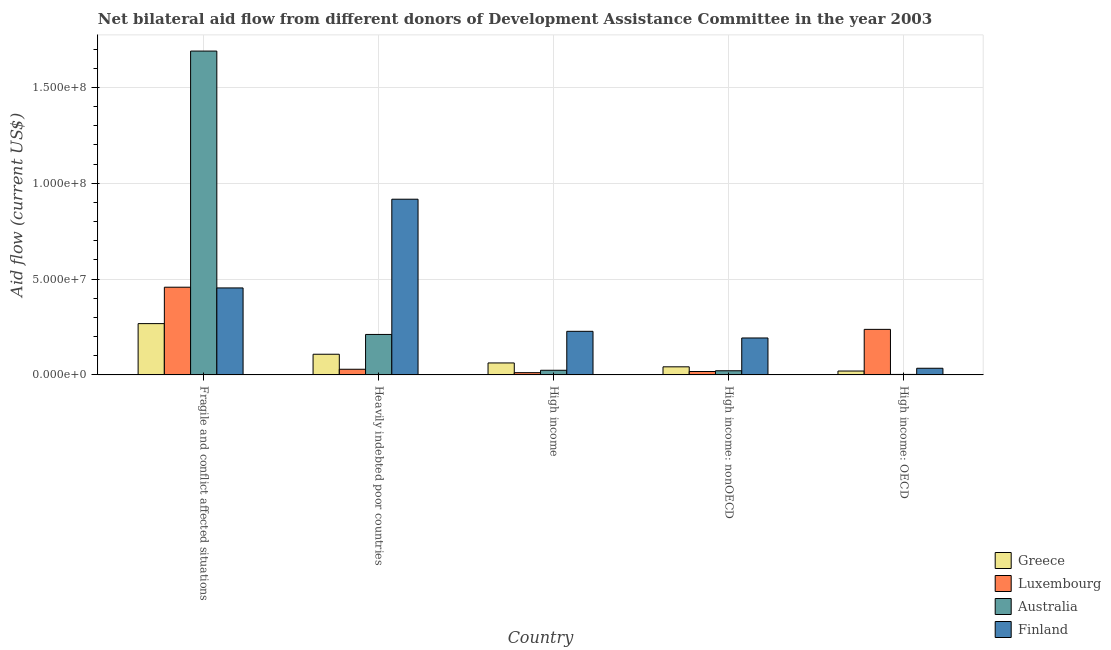How many different coloured bars are there?
Ensure brevity in your answer.  4. Are the number of bars per tick equal to the number of legend labels?
Offer a very short reply. Yes. How many bars are there on the 4th tick from the left?
Your response must be concise. 4. How many bars are there on the 4th tick from the right?
Your response must be concise. 4. What is the label of the 3rd group of bars from the left?
Offer a very short reply. High income. What is the amount of aid given by greece in High income: OECD?
Make the answer very short. 2.02e+06. Across all countries, what is the maximum amount of aid given by luxembourg?
Your answer should be very brief. 4.58e+07. Across all countries, what is the minimum amount of aid given by finland?
Ensure brevity in your answer.  3.47e+06. In which country was the amount of aid given by luxembourg maximum?
Provide a short and direct response. Fragile and conflict affected situations. In which country was the amount of aid given by greece minimum?
Make the answer very short. High income: OECD. What is the total amount of aid given by finland in the graph?
Your response must be concise. 1.83e+08. What is the difference between the amount of aid given by greece in High income and that in High income: OECD?
Give a very brief answer. 4.22e+06. What is the difference between the amount of aid given by australia in High income and the amount of aid given by finland in Fragile and conflict affected situations?
Make the answer very short. -4.30e+07. What is the average amount of aid given by luxembourg per country?
Provide a short and direct response. 1.51e+07. What is the difference between the amount of aid given by luxembourg and amount of aid given by australia in High income: OECD?
Keep it short and to the point. 2.35e+07. What is the ratio of the amount of aid given by luxembourg in Heavily indebted poor countries to that in High income: OECD?
Your answer should be compact. 0.12. Is the amount of aid given by greece in Heavily indebted poor countries less than that in High income: OECD?
Give a very brief answer. No. What is the difference between the highest and the second highest amount of aid given by luxembourg?
Offer a terse response. 2.20e+07. What is the difference between the highest and the lowest amount of aid given by australia?
Your response must be concise. 1.69e+08. Is the sum of the amount of aid given by finland in Heavily indebted poor countries and High income: OECD greater than the maximum amount of aid given by luxembourg across all countries?
Offer a terse response. Yes. Is it the case that in every country, the sum of the amount of aid given by luxembourg and amount of aid given by greece is greater than the sum of amount of aid given by finland and amount of aid given by australia?
Keep it short and to the point. No. What does the 2nd bar from the right in High income: OECD represents?
Offer a very short reply. Australia. Is it the case that in every country, the sum of the amount of aid given by greece and amount of aid given by luxembourg is greater than the amount of aid given by australia?
Give a very brief answer. No. How many bars are there?
Offer a very short reply. 20. How many countries are there in the graph?
Make the answer very short. 5. What is the difference between two consecutive major ticks on the Y-axis?
Provide a succinct answer. 5.00e+07. Does the graph contain grids?
Give a very brief answer. Yes. Where does the legend appear in the graph?
Your answer should be very brief. Bottom right. How many legend labels are there?
Give a very brief answer. 4. How are the legend labels stacked?
Keep it short and to the point. Vertical. What is the title of the graph?
Your response must be concise. Net bilateral aid flow from different donors of Development Assistance Committee in the year 2003. Does "UNRWA" appear as one of the legend labels in the graph?
Ensure brevity in your answer.  No. What is the label or title of the X-axis?
Your answer should be very brief. Country. What is the Aid flow (current US$) of Greece in Fragile and conflict affected situations?
Your answer should be very brief. 2.68e+07. What is the Aid flow (current US$) in Luxembourg in Fragile and conflict affected situations?
Offer a terse response. 4.58e+07. What is the Aid flow (current US$) of Australia in Fragile and conflict affected situations?
Offer a very short reply. 1.69e+08. What is the Aid flow (current US$) of Finland in Fragile and conflict affected situations?
Your answer should be compact. 4.54e+07. What is the Aid flow (current US$) of Greece in Heavily indebted poor countries?
Offer a very short reply. 1.08e+07. What is the Aid flow (current US$) in Luxembourg in Heavily indebted poor countries?
Offer a terse response. 2.95e+06. What is the Aid flow (current US$) in Australia in Heavily indebted poor countries?
Keep it short and to the point. 2.11e+07. What is the Aid flow (current US$) of Finland in Heavily indebted poor countries?
Make the answer very short. 9.17e+07. What is the Aid flow (current US$) of Greece in High income?
Provide a succinct answer. 6.24e+06. What is the Aid flow (current US$) of Luxembourg in High income?
Your answer should be compact. 1.17e+06. What is the Aid flow (current US$) of Australia in High income?
Your answer should be compact. 2.42e+06. What is the Aid flow (current US$) in Finland in High income?
Give a very brief answer. 2.27e+07. What is the Aid flow (current US$) of Greece in High income: nonOECD?
Offer a terse response. 4.22e+06. What is the Aid flow (current US$) of Luxembourg in High income: nonOECD?
Make the answer very short. 1.78e+06. What is the Aid flow (current US$) in Australia in High income: nonOECD?
Offer a terse response. 2.17e+06. What is the Aid flow (current US$) of Finland in High income: nonOECD?
Offer a very short reply. 1.93e+07. What is the Aid flow (current US$) of Greece in High income: OECD?
Your answer should be compact. 2.02e+06. What is the Aid flow (current US$) of Luxembourg in High income: OECD?
Offer a very short reply. 2.38e+07. What is the Aid flow (current US$) in Finland in High income: OECD?
Provide a short and direct response. 3.47e+06. Across all countries, what is the maximum Aid flow (current US$) of Greece?
Offer a very short reply. 2.68e+07. Across all countries, what is the maximum Aid flow (current US$) in Luxembourg?
Your response must be concise. 4.58e+07. Across all countries, what is the maximum Aid flow (current US$) of Australia?
Give a very brief answer. 1.69e+08. Across all countries, what is the maximum Aid flow (current US$) in Finland?
Ensure brevity in your answer.  9.17e+07. Across all countries, what is the minimum Aid flow (current US$) in Greece?
Make the answer very short. 2.02e+06. Across all countries, what is the minimum Aid flow (current US$) of Luxembourg?
Your answer should be compact. 1.17e+06. Across all countries, what is the minimum Aid flow (current US$) of Australia?
Ensure brevity in your answer.  2.50e+05. Across all countries, what is the minimum Aid flow (current US$) in Finland?
Keep it short and to the point. 3.47e+06. What is the total Aid flow (current US$) of Greece in the graph?
Make the answer very short. 5.00e+07. What is the total Aid flow (current US$) of Luxembourg in the graph?
Offer a very short reply. 7.54e+07. What is the total Aid flow (current US$) in Australia in the graph?
Your response must be concise. 1.95e+08. What is the total Aid flow (current US$) in Finland in the graph?
Make the answer very short. 1.83e+08. What is the difference between the Aid flow (current US$) in Greece in Fragile and conflict affected situations and that in Heavily indebted poor countries?
Offer a very short reply. 1.60e+07. What is the difference between the Aid flow (current US$) of Luxembourg in Fragile and conflict affected situations and that in Heavily indebted poor countries?
Ensure brevity in your answer.  4.28e+07. What is the difference between the Aid flow (current US$) of Australia in Fragile and conflict affected situations and that in Heavily indebted poor countries?
Give a very brief answer. 1.48e+08. What is the difference between the Aid flow (current US$) of Finland in Fragile and conflict affected situations and that in Heavily indebted poor countries?
Give a very brief answer. -4.63e+07. What is the difference between the Aid flow (current US$) in Greece in Fragile and conflict affected situations and that in High income?
Your response must be concise. 2.05e+07. What is the difference between the Aid flow (current US$) of Luxembourg in Fragile and conflict affected situations and that in High income?
Offer a very short reply. 4.46e+07. What is the difference between the Aid flow (current US$) of Australia in Fragile and conflict affected situations and that in High income?
Ensure brevity in your answer.  1.67e+08. What is the difference between the Aid flow (current US$) in Finland in Fragile and conflict affected situations and that in High income?
Give a very brief answer. 2.26e+07. What is the difference between the Aid flow (current US$) of Greece in Fragile and conflict affected situations and that in High income: nonOECD?
Your answer should be compact. 2.25e+07. What is the difference between the Aid flow (current US$) of Luxembourg in Fragile and conflict affected situations and that in High income: nonOECD?
Your answer should be very brief. 4.40e+07. What is the difference between the Aid flow (current US$) in Australia in Fragile and conflict affected situations and that in High income: nonOECD?
Ensure brevity in your answer.  1.67e+08. What is the difference between the Aid flow (current US$) of Finland in Fragile and conflict affected situations and that in High income: nonOECD?
Make the answer very short. 2.61e+07. What is the difference between the Aid flow (current US$) in Greece in Fragile and conflict affected situations and that in High income: OECD?
Your answer should be compact. 2.47e+07. What is the difference between the Aid flow (current US$) of Luxembourg in Fragile and conflict affected situations and that in High income: OECD?
Ensure brevity in your answer.  2.20e+07. What is the difference between the Aid flow (current US$) in Australia in Fragile and conflict affected situations and that in High income: OECD?
Provide a short and direct response. 1.69e+08. What is the difference between the Aid flow (current US$) of Finland in Fragile and conflict affected situations and that in High income: OECD?
Provide a short and direct response. 4.19e+07. What is the difference between the Aid flow (current US$) of Greece in Heavily indebted poor countries and that in High income?
Ensure brevity in your answer.  4.54e+06. What is the difference between the Aid flow (current US$) of Luxembourg in Heavily indebted poor countries and that in High income?
Your answer should be compact. 1.78e+06. What is the difference between the Aid flow (current US$) of Australia in Heavily indebted poor countries and that in High income?
Your answer should be compact. 1.87e+07. What is the difference between the Aid flow (current US$) of Finland in Heavily indebted poor countries and that in High income?
Provide a short and direct response. 6.89e+07. What is the difference between the Aid flow (current US$) in Greece in Heavily indebted poor countries and that in High income: nonOECD?
Provide a succinct answer. 6.56e+06. What is the difference between the Aid flow (current US$) in Luxembourg in Heavily indebted poor countries and that in High income: nonOECD?
Offer a very short reply. 1.17e+06. What is the difference between the Aid flow (current US$) of Australia in Heavily indebted poor countries and that in High income: nonOECD?
Your answer should be very brief. 1.89e+07. What is the difference between the Aid flow (current US$) of Finland in Heavily indebted poor countries and that in High income: nonOECD?
Your answer should be very brief. 7.24e+07. What is the difference between the Aid flow (current US$) in Greece in Heavily indebted poor countries and that in High income: OECD?
Your response must be concise. 8.76e+06. What is the difference between the Aid flow (current US$) of Luxembourg in Heavily indebted poor countries and that in High income: OECD?
Ensure brevity in your answer.  -2.08e+07. What is the difference between the Aid flow (current US$) of Australia in Heavily indebted poor countries and that in High income: OECD?
Offer a very short reply. 2.09e+07. What is the difference between the Aid flow (current US$) in Finland in Heavily indebted poor countries and that in High income: OECD?
Your answer should be very brief. 8.82e+07. What is the difference between the Aid flow (current US$) in Greece in High income and that in High income: nonOECD?
Provide a short and direct response. 2.02e+06. What is the difference between the Aid flow (current US$) in Luxembourg in High income and that in High income: nonOECD?
Provide a short and direct response. -6.10e+05. What is the difference between the Aid flow (current US$) of Finland in High income and that in High income: nonOECD?
Provide a short and direct response. 3.47e+06. What is the difference between the Aid flow (current US$) of Greece in High income and that in High income: OECD?
Keep it short and to the point. 4.22e+06. What is the difference between the Aid flow (current US$) in Luxembourg in High income and that in High income: OECD?
Provide a succinct answer. -2.26e+07. What is the difference between the Aid flow (current US$) in Australia in High income and that in High income: OECD?
Offer a very short reply. 2.17e+06. What is the difference between the Aid flow (current US$) of Finland in High income and that in High income: OECD?
Offer a very short reply. 1.93e+07. What is the difference between the Aid flow (current US$) in Greece in High income: nonOECD and that in High income: OECD?
Offer a terse response. 2.20e+06. What is the difference between the Aid flow (current US$) in Luxembourg in High income: nonOECD and that in High income: OECD?
Keep it short and to the point. -2.20e+07. What is the difference between the Aid flow (current US$) in Australia in High income: nonOECD and that in High income: OECD?
Provide a succinct answer. 1.92e+06. What is the difference between the Aid flow (current US$) of Finland in High income: nonOECD and that in High income: OECD?
Make the answer very short. 1.58e+07. What is the difference between the Aid flow (current US$) in Greece in Fragile and conflict affected situations and the Aid flow (current US$) in Luxembourg in Heavily indebted poor countries?
Keep it short and to the point. 2.38e+07. What is the difference between the Aid flow (current US$) of Greece in Fragile and conflict affected situations and the Aid flow (current US$) of Australia in Heavily indebted poor countries?
Your answer should be very brief. 5.65e+06. What is the difference between the Aid flow (current US$) of Greece in Fragile and conflict affected situations and the Aid flow (current US$) of Finland in Heavily indebted poor countries?
Ensure brevity in your answer.  -6.49e+07. What is the difference between the Aid flow (current US$) in Luxembourg in Fragile and conflict affected situations and the Aid flow (current US$) in Australia in Heavily indebted poor countries?
Offer a very short reply. 2.46e+07. What is the difference between the Aid flow (current US$) of Luxembourg in Fragile and conflict affected situations and the Aid flow (current US$) of Finland in Heavily indebted poor countries?
Make the answer very short. -4.59e+07. What is the difference between the Aid flow (current US$) in Australia in Fragile and conflict affected situations and the Aid flow (current US$) in Finland in Heavily indebted poor countries?
Ensure brevity in your answer.  7.73e+07. What is the difference between the Aid flow (current US$) of Greece in Fragile and conflict affected situations and the Aid flow (current US$) of Luxembourg in High income?
Your answer should be very brief. 2.56e+07. What is the difference between the Aid flow (current US$) of Greece in Fragile and conflict affected situations and the Aid flow (current US$) of Australia in High income?
Give a very brief answer. 2.43e+07. What is the difference between the Aid flow (current US$) in Greece in Fragile and conflict affected situations and the Aid flow (current US$) in Finland in High income?
Make the answer very short. 4.02e+06. What is the difference between the Aid flow (current US$) in Luxembourg in Fragile and conflict affected situations and the Aid flow (current US$) in Australia in High income?
Keep it short and to the point. 4.33e+07. What is the difference between the Aid flow (current US$) of Luxembourg in Fragile and conflict affected situations and the Aid flow (current US$) of Finland in High income?
Your answer should be very brief. 2.30e+07. What is the difference between the Aid flow (current US$) in Australia in Fragile and conflict affected situations and the Aid flow (current US$) in Finland in High income?
Your answer should be compact. 1.46e+08. What is the difference between the Aid flow (current US$) of Greece in Fragile and conflict affected situations and the Aid flow (current US$) of Luxembourg in High income: nonOECD?
Your answer should be very brief. 2.50e+07. What is the difference between the Aid flow (current US$) of Greece in Fragile and conflict affected situations and the Aid flow (current US$) of Australia in High income: nonOECD?
Ensure brevity in your answer.  2.46e+07. What is the difference between the Aid flow (current US$) in Greece in Fragile and conflict affected situations and the Aid flow (current US$) in Finland in High income: nonOECD?
Ensure brevity in your answer.  7.49e+06. What is the difference between the Aid flow (current US$) in Luxembourg in Fragile and conflict affected situations and the Aid flow (current US$) in Australia in High income: nonOECD?
Give a very brief answer. 4.36e+07. What is the difference between the Aid flow (current US$) in Luxembourg in Fragile and conflict affected situations and the Aid flow (current US$) in Finland in High income: nonOECD?
Provide a short and direct response. 2.65e+07. What is the difference between the Aid flow (current US$) of Australia in Fragile and conflict affected situations and the Aid flow (current US$) of Finland in High income: nonOECD?
Make the answer very short. 1.50e+08. What is the difference between the Aid flow (current US$) in Greece in Fragile and conflict affected situations and the Aid flow (current US$) in Australia in High income: OECD?
Keep it short and to the point. 2.65e+07. What is the difference between the Aid flow (current US$) of Greece in Fragile and conflict affected situations and the Aid flow (current US$) of Finland in High income: OECD?
Provide a succinct answer. 2.33e+07. What is the difference between the Aid flow (current US$) in Luxembourg in Fragile and conflict affected situations and the Aid flow (current US$) in Australia in High income: OECD?
Make the answer very short. 4.55e+07. What is the difference between the Aid flow (current US$) in Luxembourg in Fragile and conflict affected situations and the Aid flow (current US$) in Finland in High income: OECD?
Your response must be concise. 4.23e+07. What is the difference between the Aid flow (current US$) in Australia in Fragile and conflict affected situations and the Aid flow (current US$) in Finland in High income: OECD?
Provide a succinct answer. 1.65e+08. What is the difference between the Aid flow (current US$) in Greece in Heavily indebted poor countries and the Aid flow (current US$) in Luxembourg in High income?
Offer a terse response. 9.61e+06. What is the difference between the Aid flow (current US$) in Greece in Heavily indebted poor countries and the Aid flow (current US$) in Australia in High income?
Your response must be concise. 8.36e+06. What is the difference between the Aid flow (current US$) in Greece in Heavily indebted poor countries and the Aid flow (current US$) in Finland in High income?
Give a very brief answer. -1.20e+07. What is the difference between the Aid flow (current US$) of Luxembourg in Heavily indebted poor countries and the Aid flow (current US$) of Australia in High income?
Offer a terse response. 5.30e+05. What is the difference between the Aid flow (current US$) of Luxembourg in Heavily indebted poor countries and the Aid flow (current US$) of Finland in High income?
Your answer should be very brief. -1.98e+07. What is the difference between the Aid flow (current US$) of Australia in Heavily indebted poor countries and the Aid flow (current US$) of Finland in High income?
Provide a short and direct response. -1.63e+06. What is the difference between the Aid flow (current US$) in Greece in Heavily indebted poor countries and the Aid flow (current US$) in Luxembourg in High income: nonOECD?
Your answer should be very brief. 9.00e+06. What is the difference between the Aid flow (current US$) of Greece in Heavily indebted poor countries and the Aid flow (current US$) of Australia in High income: nonOECD?
Ensure brevity in your answer.  8.61e+06. What is the difference between the Aid flow (current US$) in Greece in Heavily indebted poor countries and the Aid flow (current US$) in Finland in High income: nonOECD?
Your answer should be compact. -8.49e+06. What is the difference between the Aid flow (current US$) of Luxembourg in Heavily indebted poor countries and the Aid flow (current US$) of Australia in High income: nonOECD?
Keep it short and to the point. 7.80e+05. What is the difference between the Aid flow (current US$) of Luxembourg in Heavily indebted poor countries and the Aid flow (current US$) of Finland in High income: nonOECD?
Offer a terse response. -1.63e+07. What is the difference between the Aid flow (current US$) of Australia in Heavily indebted poor countries and the Aid flow (current US$) of Finland in High income: nonOECD?
Offer a terse response. 1.84e+06. What is the difference between the Aid flow (current US$) in Greece in Heavily indebted poor countries and the Aid flow (current US$) in Luxembourg in High income: OECD?
Offer a terse response. -1.30e+07. What is the difference between the Aid flow (current US$) of Greece in Heavily indebted poor countries and the Aid flow (current US$) of Australia in High income: OECD?
Offer a very short reply. 1.05e+07. What is the difference between the Aid flow (current US$) of Greece in Heavily indebted poor countries and the Aid flow (current US$) of Finland in High income: OECD?
Ensure brevity in your answer.  7.31e+06. What is the difference between the Aid flow (current US$) in Luxembourg in Heavily indebted poor countries and the Aid flow (current US$) in Australia in High income: OECD?
Your answer should be compact. 2.70e+06. What is the difference between the Aid flow (current US$) in Luxembourg in Heavily indebted poor countries and the Aid flow (current US$) in Finland in High income: OECD?
Offer a very short reply. -5.20e+05. What is the difference between the Aid flow (current US$) of Australia in Heavily indebted poor countries and the Aid flow (current US$) of Finland in High income: OECD?
Offer a terse response. 1.76e+07. What is the difference between the Aid flow (current US$) of Greece in High income and the Aid flow (current US$) of Luxembourg in High income: nonOECD?
Your response must be concise. 4.46e+06. What is the difference between the Aid flow (current US$) in Greece in High income and the Aid flow (current US$) in Australia in High income: nonOECD?
Give a very brief answer. 4.07e+06. What is the difference between the Aid flow (current US$) of Greece in High income and the Aid flow (current US$) of Finland in High income: nonOECD?
Keep it short and to the point. -1.30e+07. What is the difference between the Aid flow (current US$) in Luxembourg in High income and the Aid flow (current US$) in Australia in High income: nonOECD?
Provide a short and direct response. -1.00e+06. What is the difference between the Aid flow (current US$) in Luxembourg in High income and the Aid flow (current US$) in Finland in High income: nonOECD?
Make the answer very short. -1.81e+07. What is the difference between the Aid flow (current US$) in Australia in High income and the Aid flow (current US$) in Finland in High income: nonOECD?
Provide a succinct answer. -1.68e+07. What is the difference between the Aid flow (current US$) in Greece in High income and the Aid flow (current US$) in Luxembourg in High income: OECD?
Your response must be concise. -1.75e+07. What is the difference between the Aid flow (current US$) of Greece in High income and the Aid flow (current US$) of Australia in High income: OECD?
Your answer should be compact. 5.99e+06. What is the difference between the Aid flow (current US$) of Greece in High income and the Aid flow (current US$) of Finland in High income: OECD?
Ensure brevity in your answer.  2.77e+06. What is the difference between the Aid flow (current US$) in Luxembourg in High income and the Aid flow (current US$) in Australia in High income: OECD?
Your response must be concise. 9.20e+05. What is the difference between the Aid flow (current US$) in Luxembourg in High income and the Aid flow (current US$) in Finland in High income: OECD?
Provide a succinct answer. -2.30e+06. What is the difference between the Aid flow (current US$) in Australia in High income and the Aid flow (current US$) in Finland in High income: OECD?
Your answer should be compact. -1.05e+06. What is the difference between the Aid flow (current US$) of Greece in High income: nonOECD and the Aid flow (current US$) of Luxembourg in High income: OECD?
Your answer should be very brief. -1.95e+07. What is the difference between the Aid flow (current US$) in Greece in High income: nonOECD and the Aid flow (current US$) in Australia in High income: OECD?
Ensure brevity in your answer.  3.97e+06. What is the difference between the Aid flow (current US$) in Greece in High income: nonOECD and the Aid flow (current US$) in Finland in High income: OECD?
Keep it short and to the point. 7.50e+05. What is the difference between the Aid flow (current US$) in Luxembourg in High income: nonOECD and the Aid flow (current US$) in Australia in High income: OECD?
Offer a terse response. 1.53e+06. What is the difference between the Aid flow (current US$) of Luxembourg in High income: nonOECD and the Aid flow (current US$) of Finland in High income: OECD?
Provide a short and direct response. -1.69e+06. What is the difference between the Aid flow (current US$) of Australia in High income: nonOECD and the Aid flow (current US$) of Finland in High income: OECD?
Your answer should be compact. -1.30e+06. What is the average Aid flow (current US$) of Greece per country?
Your answer should be very brief. 1.00e+07. What is the average Aid flow (current US$) in Luxembourg per country?
Ensure brevity in your answer.  1.51e+07. What is the average Aid flow (current US$) of Australia per country?
Offer a terse response. 3.90e+07. What is the average Aid flow (current US$) of Finland per country?
Your answer should be very brief. 3.65e+07. What is the difference between the Aid flow (current US$) of Greece and Aid flow (current US$) of Luxembourg in Fragile and conflict affected situations?
Provide a succinct answer. -1.90e+07. What is the difference between the Aid flow (current US$) in Greece and Aid flow (current US$) in Australia in Fragile and conflict affected situations?
Ensure brevity in your answer.  -1.42e+08. What is the difference between the Aid flow (current US$) in Greece and Aid flow (current US$) in Finland in Fragile and conflict affected situations?
Offer a terse response. -1.86e+07. What is the difference between the Aid flow (current US$) of Luxembourg and Aid flow (current US$) of Australia in Fragile and conflict affected situations?
Make the answer very short. -1.23e+08. What is the difference between the Aid flow (current US$) in Luxembourg and Aid flow (current US$) in Finland in Fragile and conflict affected situations?
Offer a very short reply. 3.80e+05. What is the difference between the Aid flow (current US$) of Australia and Aid flow (current US$) of Finland in Fragile and conflict affected situations?
Offer a terse response. 1.24e+08. What is the difference between the Aid flow (current US$) of Greece and Aid flow (current US$) of Luxembourg in Heavily indebted poor countries?
Ensure brevity in your answer.  7.83e+06. What is the difference between the Aid flow (current US$) in Greece and Aid flow (current US$) in Australia in Heavily indebted poor countries?
Make the answer very short. -1.03e+07. What is the difference between the Aid flow (current US$) in Greece and Aid flow (current US$) in Finland in Heavily indebted poor countries?
Provide a succinct answer. -8.09e+07. What is the difference between the Aid flow (current US$) of Luxembourg and Aid flow (current US$) of Australia in Heavily indebted poor countries?
Offer a terse response. -1.82e+07. What is the difference between the Aid flow (current US$) of Luxembourg and Aid flow (current US$) of Finland in Heavily indebted poor countries?
Offer a terse response. -8.87e+07. What is the difference between the Aid flow (current US$) in Australia and Aid flow (current US$) in Finland in Heavily indebted poor countries?
Your response must be concise. -7.06e+07. What is the difference between the Aid flow (current US$) of Greece and Aid flow (current US$) of Luxembourg in High income?
Provide a succinct answer. 5.07e+06. What is the difference between the Aid flow (current US$) of Greece and Aid flow (current US$) of Australia in High income?
Your answer should be very brief. 3.82e+06. What is the difference between the Aid flow (current US$) of Greece and Aid flow (current US$) of Finland in High income?
Your answer should be compact. -1.65e+07. What is the difference between the Aid flow (current US$) of Luxembourg and Aid flow (current US$) of Australia in High income?
Ensure brevity in your answer.  -1.25e+06. What is the difference between the Aid flow (current US$) of Luxembourg and Aid flow (current US$) of Finland in High income?
Provide a short and direct response. -2.16e+07. What is the difference between the Aid flow (current US$) in Australia and Aid flow (current US$) in Finland in High income?
Make the answer very short. -2.03e+07. What is the difference between the Aid flow (current US$) in Greece and Aid flow (current US$) in Luxembourg in High income: nonOECD?
Your response must be concise. 2.44e+06. What is the difference between the Aid flow (current US$) in Greece and Aid flow (current US$) in Australia in High income: nonOECD?
Provide a short and direct response. 2.05e+06. What is the difference between the Aid flow (current US$) in Greece and Aid flow (current US$) in Finland in High income: nonOECD?
Offer a very short reply. -1.50e+07. What is the difference between the Aid flow (current US$) in Luxembourg and Aid flow (current US$) in Australia in High income: nonOECD?
Ensure brevity in your answer.  -3.90e+05. What is the difference between the Aid flow (current US$) of Luxembourg and Aid flow (current US$) of Finland in High income: nonOECD?
Give a very brief answer. -1.75e+07. What is the difference between the Aid flow (current US$) of Australia and Aid flow (current US$) of Finland in High income: nonOECD?
Ensure brevity in your answer.  -1.71e+07. What is the difference between the Aid flow (current US$) of Greece and Aid flow (current US$) of Luxembourg in High income: OECD?
Ensure brevity in your answer.  -2.17e+07. What is the difference between the Aid flow (current US$) of Greece and Aid flow (current US$) of Australia in High income: OECD?
Provide a succinct answer. 1.77e+06. What is the difference between the Aid flow (current US$) of Greece and Aid flow (current US$) of Finland in High income: OECD?
Your answer should be very brief. -1.45e+06. What is the difference between the Aid flow (current US$) in Luxembourg and Aid flow (current US$) in Australia in High income: OECD?
Make the answer very short. 2.35e+07. What is the difference between the Aid flow (current US$) of Luxembourg and Aid flow (current US$) of Finland in High income: OECD?
Offer a very short reply. 2.03e+07. What is the difference between the Aid flow (current US$) in Australia and Aid flow (current US$) in Finland in High income: OECD?
Ensure brevity in your answer.  -3.22e+06. What is the ratio of the Aid flow (current US$) in Greece in Fragile and conflict affected situations to that in Heavily indebted poor countries?
Give a very brief answer. 2.48. What is the ratio of the Aid flow (current US$) of Luxembourg in Fragile and conflict affected situations to that in Heavily indebted poor countries?
Keep it short and to the point. 15.51. What is the ratio of the Aid flow (current US$) of Australia in Fragile and conflict affected situations to that in Heavily indebted poor countries?
Ensure brevity in your answer.  8. What is the ratio of the Aid flow (current US$) of Finland in Fragile and conflict affected situations to that in Heavily indebted poor countries?
Offer a terse response. 0.49. What is the ratio of the Aid flow (current US$) of Greece in Fragile and conflict affected situations to that in High income?
Keep it short and to the point. 4.29. What is the ratio of the Aid flow (current US$) in Luxembourg in Fragile and conflict affected situations to that in High income?
Give a very brief answer. 39.11. What is the ratio of the Aid flow (current US$) in Australia in Fragile and conflict affected situations to that in High income?
Make the answer very short. 69.82. What is the ratio of the Aid flow (current US$) in Finland in Fragile and conflict affected situations to that in High income?
Provide a succinct answer. 2. What is the ratio of the Aid flow (current US$) in Greece in Fragile and conflict affected situations to that in High income: nonOECD?
Your answer should be very brief. 6.34. What is the ratio of the Aid flow (current US$) of Luxembourg in Fragile and conflict affected situations to that in High income: nonOECD?
Your answer should be compact. 25.71. What is the ratio of the Aid flow (current US$) of Australia in Fragile and conflict affected situations to that in High income: nonOECD?
Provide a short and direct response. 77.86. What is the ratio of the Aid flow (current US$) of Finland in Fragile and conflict affected situations to that in High income: nonOECD?
Offer a terse response. 2.35. What is the ratio of the Aid flow (current US$) of Greece in Fragile and conflict affected situations to that in High income: OECD?
Make the answer very short. 13.25. What is the ratio of the Aid flow (current US$) in Luxembourg in Fragile and conflict affected situations to that in High income: OECD?
Keep it short and to the point. 1.93. What is the ratio of the Aid flow (current US$) in Australia in Fragile and conflict affected situations to that in High income: OECD?
Your answer should be very brief. 675.84. What is the ratio of the Aid flow (current US$) in Finland in Fragile and conflict affected situations to that in High income: OECD?
Offer a very short reply. 13.08. What is the ratio of the Aid flow (current US$) in Greece in Heavily indebted poor countries to that in High income?
Offer a terse response. 1.73. What is the ratio of the Aid flow (current US$) in Luxembourg in Heavily indebted poor countries to that in High income?
Offer a terse response. 2.52. What is the ratio of the Aid flow (current US$) in Australia in Heavily indebted poor countries to that in High income?
Your answer should be very brief. 8.72. What is the ratio of the Aid flow (current US$) of Finland in Heavily indebted poor countries to that in High income?
Offer a terse response. 4.03. What is the ratio of the Aid flow (current US$) of Greece in Heavily indebted poor countries to that in High income: nonOECD?
Make the answer very short. 2.55. What is the ratio of the Aid flow (current US$) of Luxembourg in Heavily indebted poor countries to that in High income: nonOECD?
Ensure brevity in your answer.  1.66. What is the ratio of the Aid flow (current US$) in Australia in Heavily indebted poor countries to that in High income: nonOECD?
Offer a terse response. 9.73. What is the ratio of the Aid flow (current US$) in Finland in Heavily indebted poor countries to that in High income: nonOECD?
Ensure brevity in your answer.  4.76. What is the ratio of the Aid flow (current US$) of Greece in Heavily indebted poor countries to that in High income: OECD?
Your answer should be very brief. 5.34. What is the ratio of the Aid flow (current US$) in Luxembourg in Heavily indebted poor countries to that in High income: OECD?
Your response must be concise. 0.12. What is the ratio of the Aid flow (current US$) in Australia in Heavily indebted poor countries to that in High income: OECD?
Your answer should be very brief. 84.44. What is the ratio of the Aid flow (current US$) in Finland in Heavily indebted poor countries to that in High income: OECD?
Make the answer very short. 26.42. What is the ratio of the Aid flow (current US$) in Greece in High income to that in High income: nonOECD?
Your answer should be compact. 1.48. What is the ratio of the Aid flow (current US$) in Luxembourg in High income to that in High income: nonOECD?
Offer a very short reply. 0.66. What is the ratio of the Aid flow (current US$) in Australia in High income to that in High income: nonOECD?
Your answer should be compact. 1.12. What is the ratio of the Aid flow (current US$) in Finland in High income to that in High income: nonOECD?
Offer a very short reply. 1.18. What is the ratio of the Aid flow (current US$) in Greece in High income to that in High income: OECD?
Offer a terse response. 3.09. What is the ratio of the Aid flow (current US$) of Luxembourg in High income to that in High income: OECD?
Provide a succinct answer. 0.05. What is the ratio of the Aid flow (current US$) of Australia in High income to that in High income: OECD?
Make the answer very short. 9.68. What is the ratio of the Aid flow (current US$) of Finland in High income to that in High income: OECD?
Provide a short and direct response. 6.55. What is the ratio of the Aid flow (current US$) in Greece in High income: nonOECD to that in High income: OECD?
Provide a short and direct response. 2.09. What is the ratio of the Aid flow (current US$) of Luxembourg in High income: nonOECD to that in High income: OECD?
Offer a very short reply. 0.07. What is the ratio of the Aid flow (current US$) of Australia in High income: nonOECD to that in High income: OECD?
Your answer should be compact. 8.68. What is the ratio of the Aid flow (current US$) in Finland in High income: nonOECD to that in High income: OECD?
Keep it short and to the point. 5.55. What is the difference between the highest and the second highest Aid flow (current US$) in Greece?
Your response must be concise. 1.60e+07. What is the difference between the highest and the second highest Aid flow (current US$) of Luxembourg?
Make the answer very short. 2.20e+07. What is the difference between the highest and the second highest Aid flow (current US$) of Australia?
Your answer should be compact. 1.48e+08. What is the difference between the highest and the second highest Aid flow (current US$) in Finland?
Provide a short and direct response. 4.63e+07. What is the difference between the highest and the lowest Aid flow (current US$) of Greece?
Keep it short and to the point. 2.47e+07. What is the difference between the highest and the lowest Aid flow (current US$) in Luxembourg?
Provide a short and direct response. 4.46e+07. What is the difference between the highest and the lowest Aid flow (current US$) in Australia?
Provide a succinct answer. 1.69e+08. What is the difference between the highest and the lowest Aid flow (current US$) in Finland?
Your answer should be compact. 8.82e+07. 